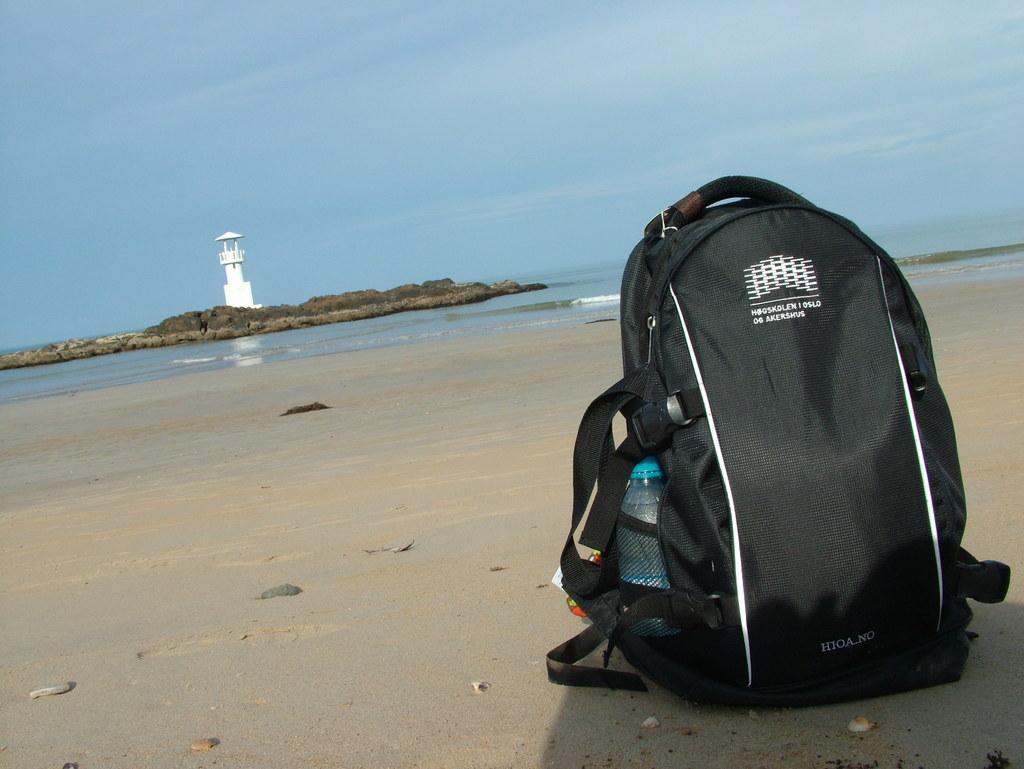How would you summarize this image in a sentence or two? It looks like this picture is taken near the sea shore. This is a black bag with a water bottle in it. At background I can see a light house which is white in color. And these are the rocks inside the sea. 